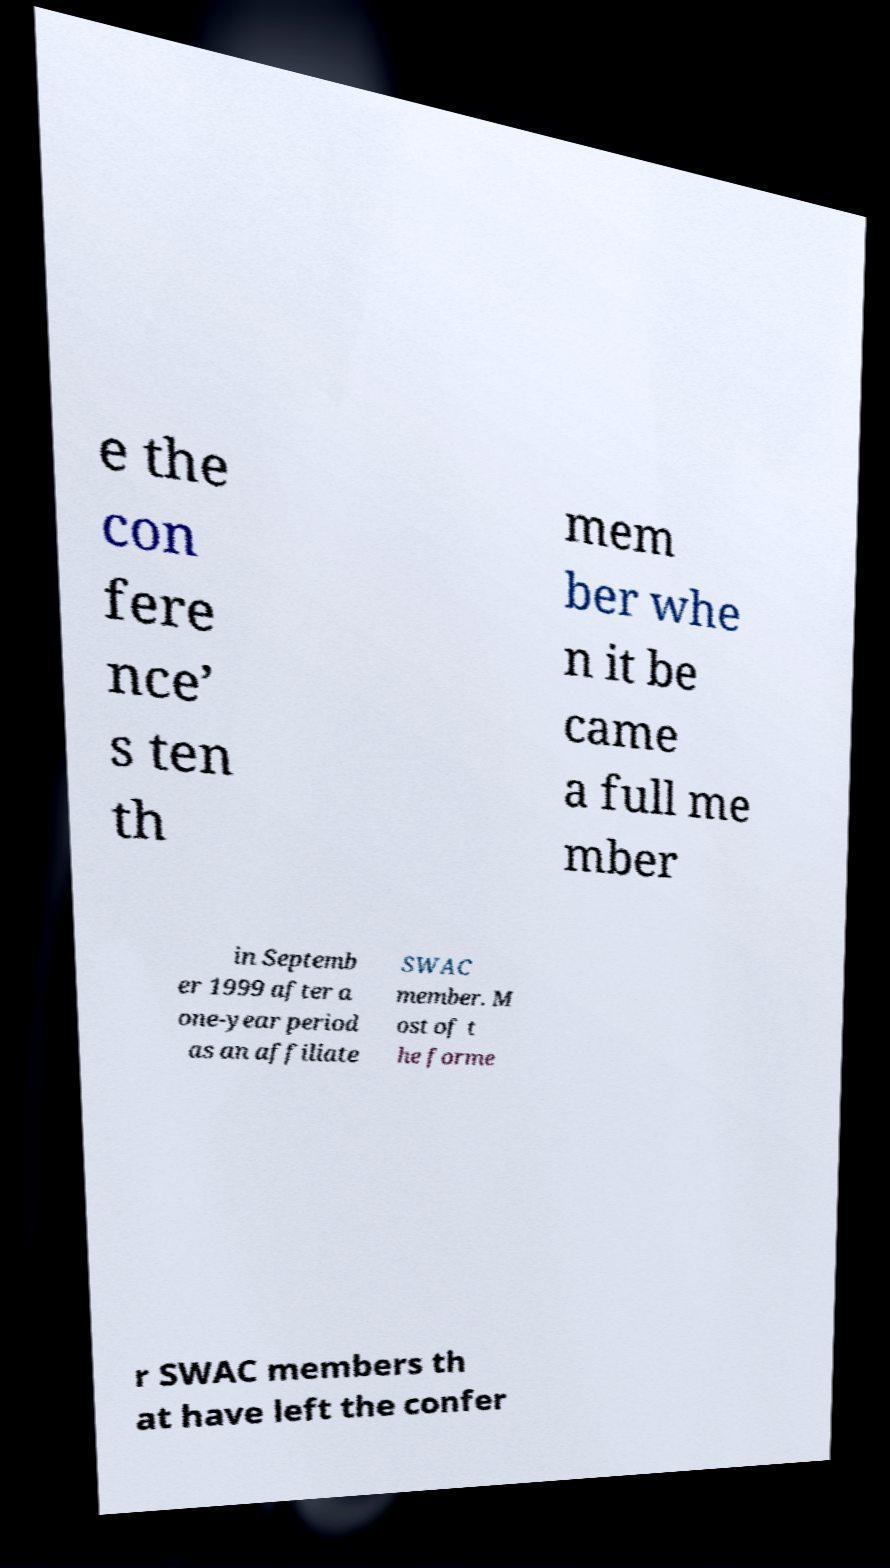Could you extract and type out the text from this image? e the con fere nce’ s ten th mem ber whe n it be came a full me mber in Septemb er 1999 after a one-year period as an affiliate SWAC member. M ost of t he forme r SWAC members th at have left the confer 